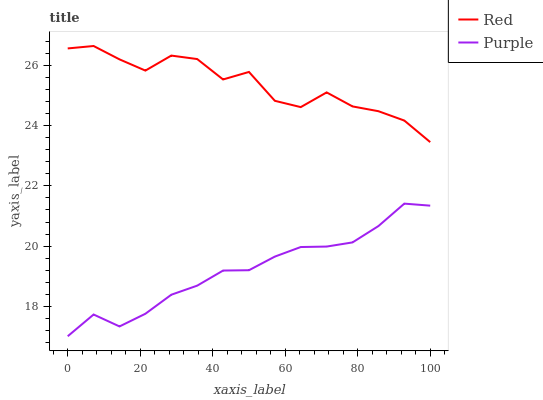Does Purple have the minimum area under the curve?
Answer yes or no. Yes. Does Red have the maximum area under the curve?
Answer yes or no. Yes. Does Red have the minimum area under the curve?
Answer yes or no. No. Is Purple the smoothest?
Answer yes or no. Yes. Is Red the roughest?
Answer yes or no. Yes. Is Red the smoothest?
Answer yes or no. No. Does Red have the lowest value?
Answer yes or no. No. Does Red have the highest value?
Answer yes or no. Yes. Is Purple less than Red?
Answer yes or no. Yes. Is Red greater than Purple?
Answer yes or no. Yes. Does Purple intersect Red?
Answer yes or no. No. 